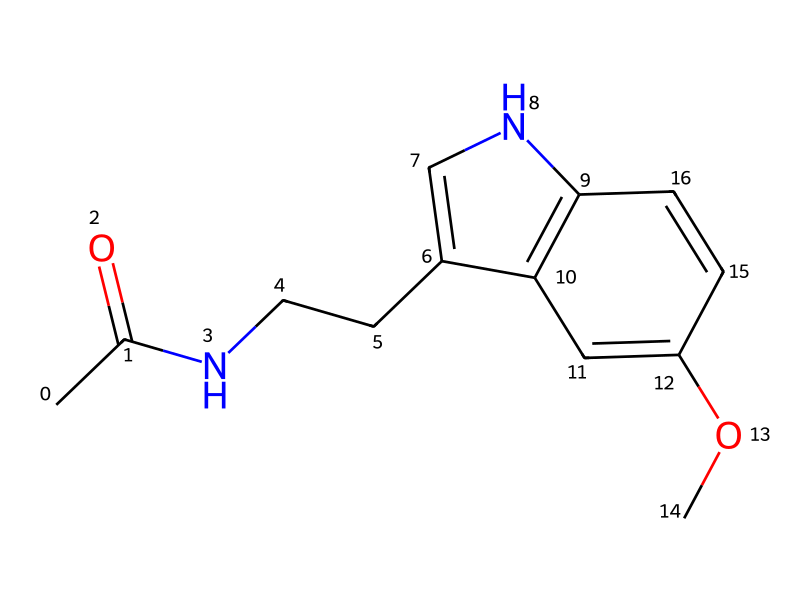How many carbon atoms are in melatonin? The SMILES representation indicates the number of carbon atoms by counting the 'C's in the string. There are in total 10 instances of 'C', which represent the carbon atoms.
Answer: 10 What functional group is present in melatonin represented in the structure? The presence of the carbonyl group (C=O) in the structure indicates that melatonin contains a ketone functional group. This is identified in the 'CC(=O)' segment of the SMILES representation.
Answer: ketone What is the molecular weight of melatonin? To compute the molecular weight, we sum the atomic weights of all atoms present in the structure based on their counts derived from the SMILES: there are 10 carbon, 12 hydrogen, 2 nitrogen, and 2 oxygen atoms which give a total molecular weight of approximately 232.28 g/mol.
Answer: 232.28 How many rings are found in the structure of melatonin? By visualizing the cycle structure in the condensed molecular structure or going through the SMILES notation, we can observe that there is one cyclic portion, specifically in the 'C1=CNc2c1cc' section, indicating one ring in the structure.
Answer: 1 Which type of chemical bonds are present in melatonin? The structure includes single bonds (between most carbon and hydrogen) and one double bond (between the carbon and oxygen in the ketone functional group). This can be deduced from the presence of '=' in 'CC(=O)'.
Answer: single and double bonds What role does melatonin serve in the body? Melatonin is primarily recognized for regulating sleep cycles, synthesized from serotonin. This is based on the biological function it's known for, though not explicitly shown in the SMILES representation.
Answer: sleep regulation Is melatonin soluble in water? Melatonin is generally considered to have low solubility in water due to its hydrophobic structure characteristics. This is because the presence of large alkyl segments limits hydrogen bonding with water molecules.
Answer: low 